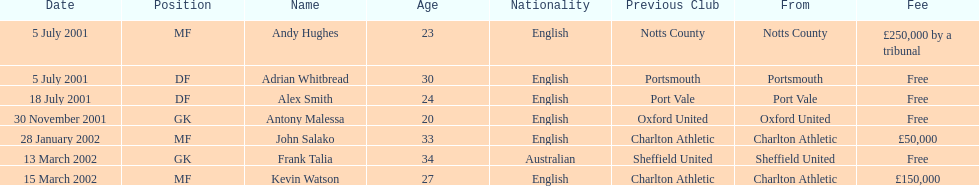What date did andy huges and adrian whitbread both move on? 5 July 2001. 